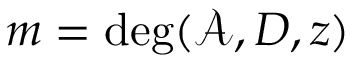Convert formula to latex. <formula><loc_0><loc_0><loc_500><loc_500>m = \deg ( \mathcal { A } , D , z )</formula> 